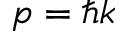Convert formula to latex. <formula><loc_0><loc_0><loc_500><loc_500>p = \hbar { k }</formula> 